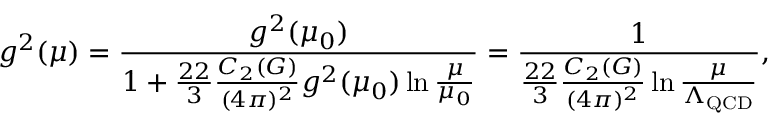Convert formula to latex. <formula><loc_0><loc_0><loc_500><loc_500>g ^ { 2 } ( \mu ) = { \frac { g ^ { 2 } ( \mu _ { 0 } ) } { 1 + { \frac { 2 2 } { 3 } } { \frac { C _ { 2 } ( G ) } { ( 4 \pi ) ^ { 2 } } } g ^ { 2 } ( \mu _ { 0 } ) \ln { \frac { \mu } { \mu _ { 0 } } } } } = { \frac { 1 } { { \frac { 2 2 } { 3 } } { \frac { C _ { 2 } ( G ) } { ( 4 \pi ) ^ { 2 } } } \ln { \frac { \mu } { \Lambda _ { Q C D } } } } } ,</formula> 